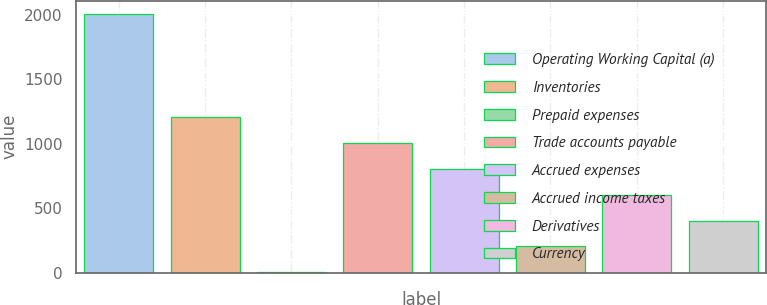Convert chart. <chart><loc_0><loc_0><loc_500><loc_500><bar_chart><fcel>Operating Working Capital (a)<fcel>Inventories<fcel>Prepaid expenses<fcel>Trade accounts payable<fcel>Accrued expenses<fcel>Accrued income taxes<fcel>Derivatives<fcel>Currency<nl><fcel>2009<fcel>1205.8<fcel>1<fcel>1005<fcel>804.2<fcel>201.8<fcel>603.4<fcel>402.6<nl></chart> 